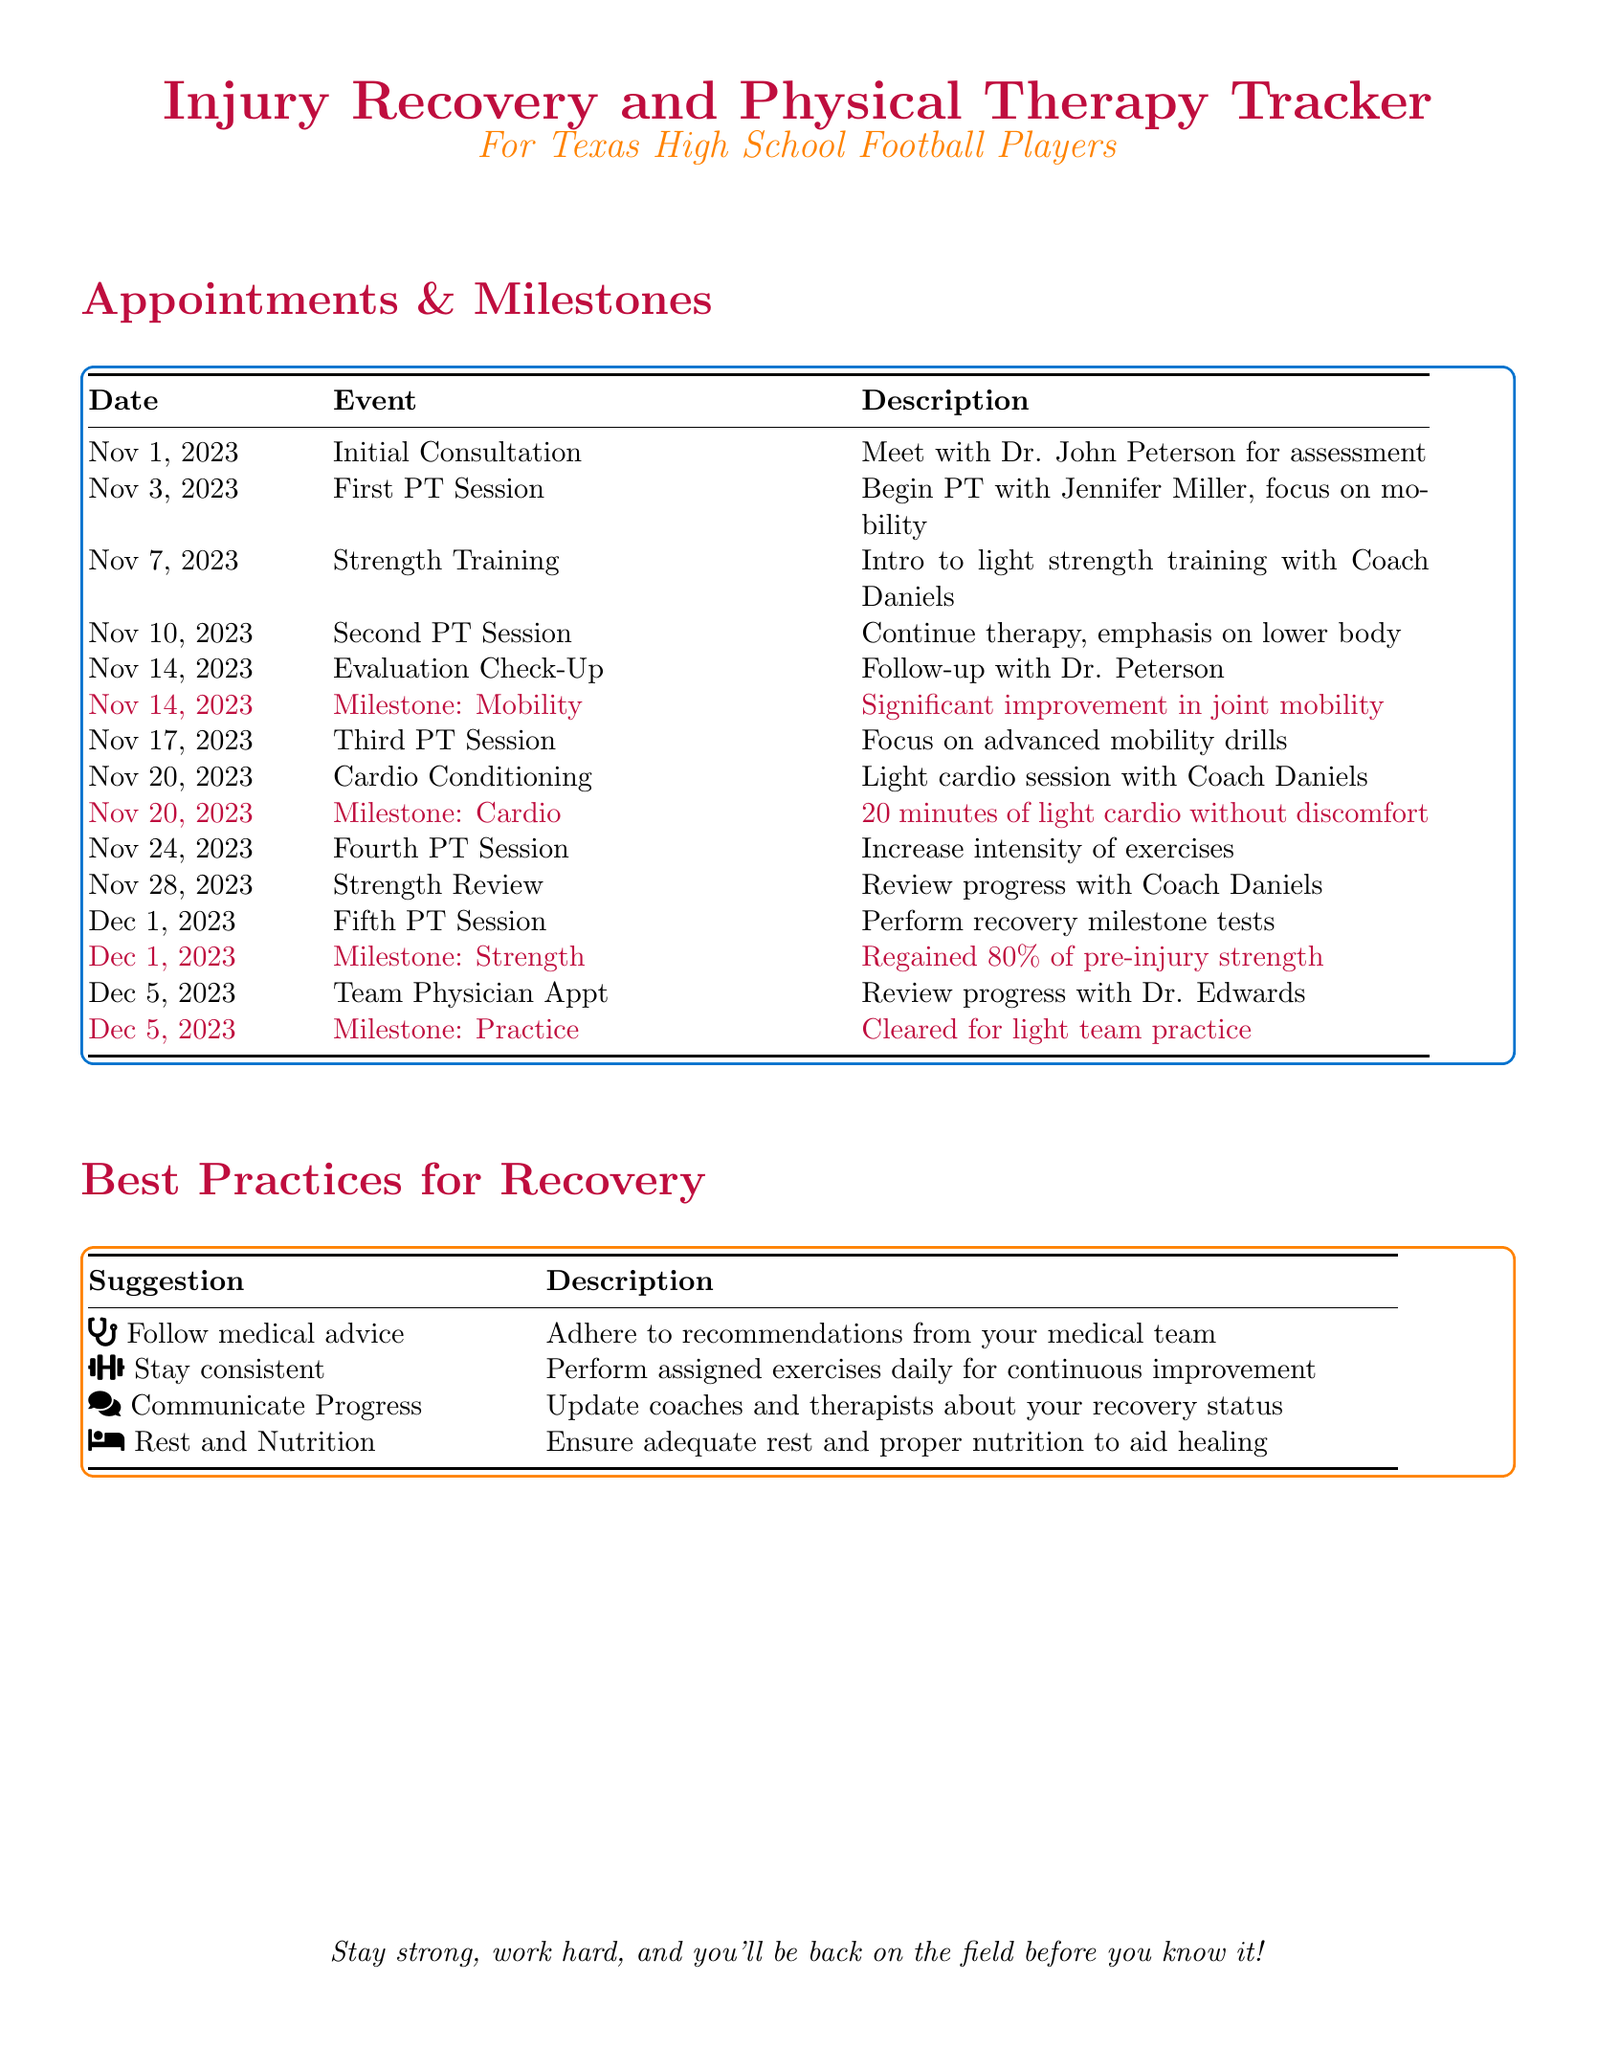What is the date of the initial consultation? The initial consultation is scheduled for November 1, 2023.
Answer: November 1, 2023 Who is the physical therapist for the first session? The physical therapist for the first session is Jennifer Miller.
Answer: Jennifer Miller What is the milestone achieved on November 14, 2023? The milestone achieved on November 14, 2023, is significant improvement in joint mobility.
Answer: Significant improvement in joint mobility How many PT sessions are scheduled before December? There are four PT sessions scheduled before December.
Answer: Four What percentage of pre-injury strength is regained by December 1, 2023? By December 1, 2023, 80% of pre-injury strength is regained.
Answer: 80% What practice milestone is set for December 5, 2023? The practice milestone is cleared for light team practice.
Answer: Cleared for light team practice Which doctor is consulted on November 14, 2023? The doctor consulted on November 14, 2023, is Dr. John Peterson.
Answer: Dr. John Peterson What is a suggested best practice for recovery? One suggested best practice for recovery is to follow medical advice.
Answer: Follow medical advice 